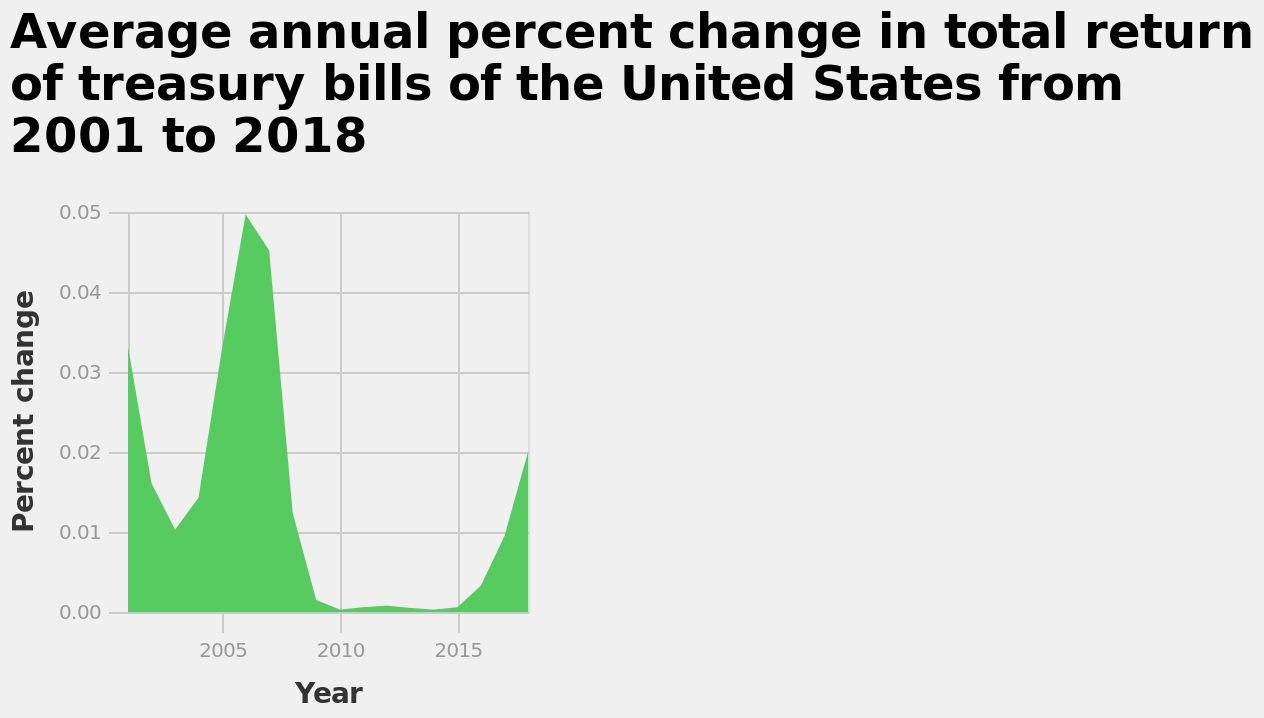<image>
Which two years saw a very small change in the total return of treasury bills? 2010 and 2015 During which years did the highest change in total return of treasury bills occur? 2006/2007 